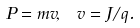Convert formula to latex. <formula><loc_0><loc_0><loc_500><loc_500>P = m v , \ v = J / q .</formula> 